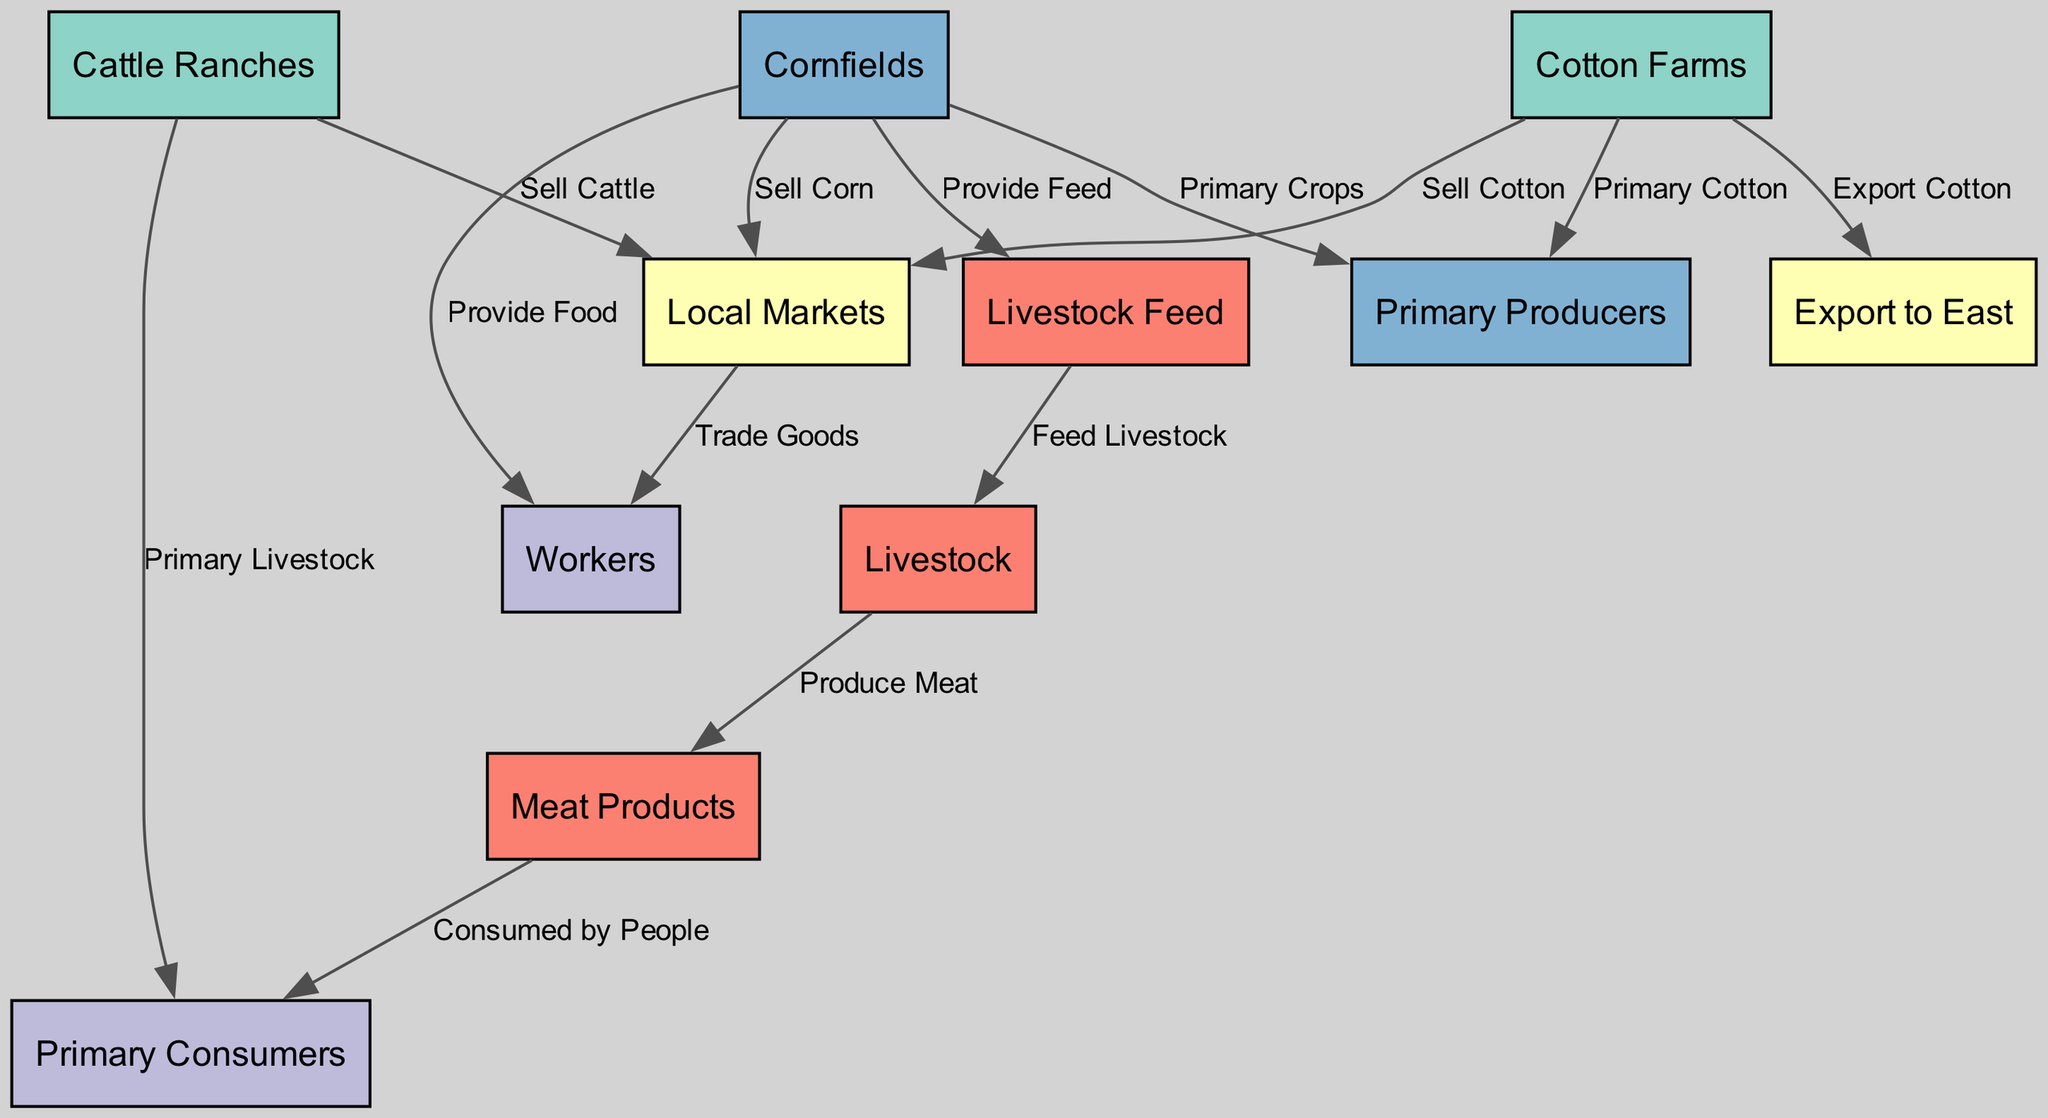What are the primary crops listed in the diagram? The nodes identified as primary crops within the diagram are "Cotton Farms" and "Cornfields," which are specifically mentioned as primary producers of crops. The label on each edge leading from these nodes denotes their role in the agricultural system.
Answer: Cotton Farms, Cornfields How many nodes represent "Markets" in the diagram? There are two specific nodes representing markets: "Local Markets" and "Export to East," as seen in the nodes listed, which depict the trading aspects of agricultural products in Texas.
Answer: 2 What do Cattle Ranches sell according to the diagram? The "Cattle Ranches" node is directly linked with the "Local Markets" node, indicating that they sell cattle as part of their agricultural output, as denoted by the label on the connecting edge.
Answer: Sell Cattle What feeds the livestock in the food chain? The diagram shows that "Livestock Feed" is provided by the "Cornfields," establishing a direct link through the edges that illustrate the flow of resources from crops to livestock.
Answer: Provide Feed Which node consumes meat products in the chain? The "Primary Consumers" node is explicitly linked to the "Meat Products" node, indicating that it is the entity consuming the meat produced from livestock in the food chain.
Answer: Primary Consumers How many edges are there leading from the Cornfields? In the diagram, there are four edges originating from the "Cornfields" node. These edges represent the multiple relationships and outputs, such as providing food, selling corn, providing feed, and serving as primary crops.
Answer: 4 Which node is directly related to producing meat? The node labeled "Produce Meat" is linked to "Livestock," illustrating that the livestock in the food chain directly relates to the production of meat products.
Answer: Livestock What is the relationship between Workers and Local Markets? The edge labeled "Trade Goods" indicates a relationship where "Local Markets" trade goods to "Workers," showing the flow of products in the market economy established in the diagram.
Answer: Trade Goods Which node is responsible for exporting cotton? The edge labeled "Export Cotton" indicates that "Cotton Farms" is the node responsible for exporting cotton to other regions, reflecting its role in the agricultural trade of Texas.
Answer: Cotton Farms 